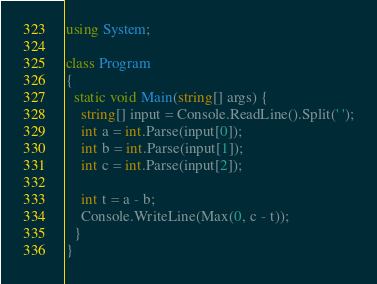<code> <loc_0><loc_0><loc_500><loc_500><_C#_>using System;

class Program 
{
  static void Main(string[] args) {
    string[] input = Console.ReadLine().Split(' ');
    int a = int.Parse(input[0]);
    int b = int.Parse(input[1]);
    int c = int.Parse(input[2]);

    int t = a - b;
    Console.WriteLine(Max(0, c - t));
  }
}</code> 